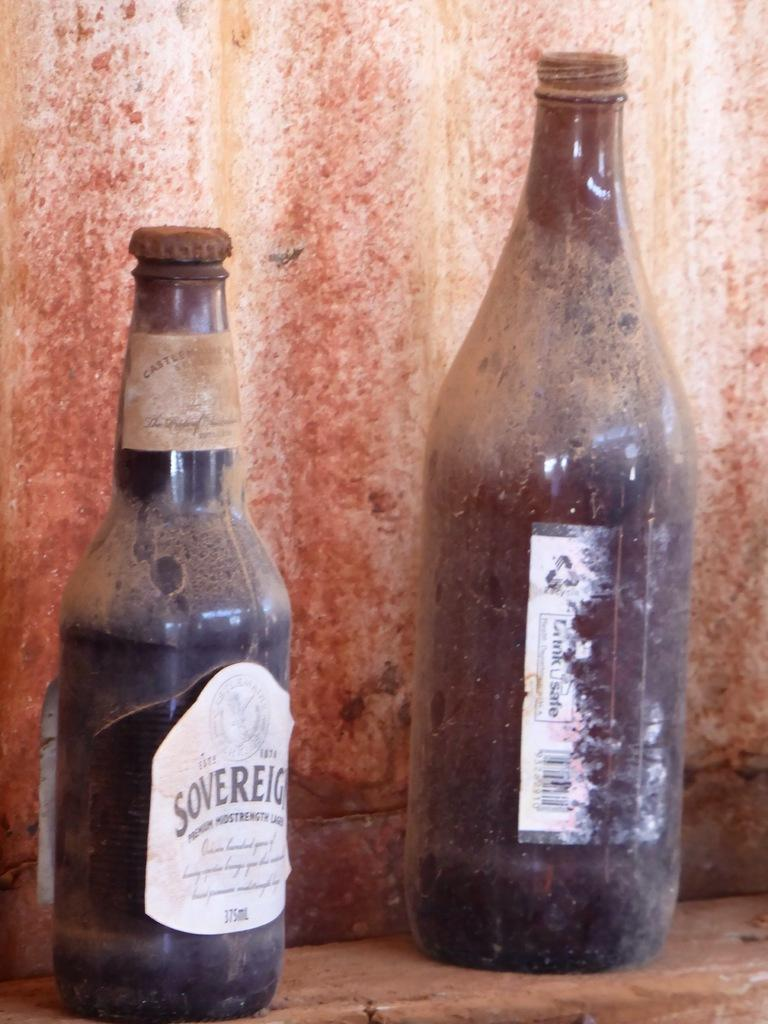Provide a one-sentence caption for the provided image. Two dusty old beer bottles sit on a shelf including one labeled Soverign. 